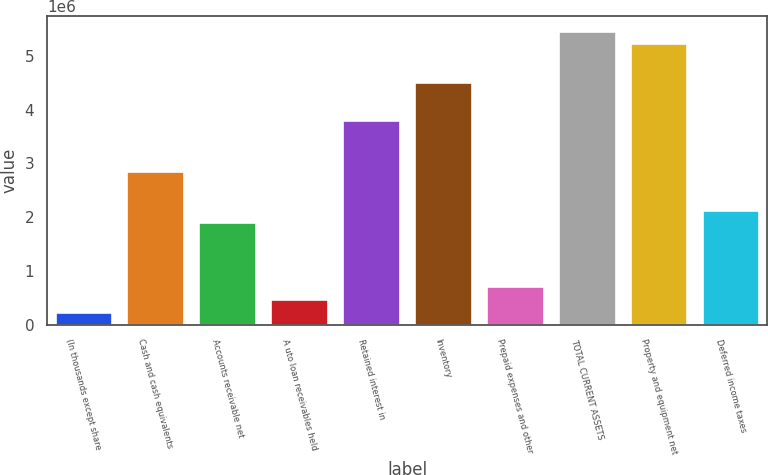Convert chart. <chart><loc_0><loc_0><loc_500><loc_500><bar_chart><fcel>(In thousands except share<fcel>Cash and cash equivalents<fcel>Accounts receivable net<fcel>A uto loan receivables held<fcel>Retained interest in<fcel>Inventory<fcel>Prepaid expenses and other<fcel>TOTAL CURRENT ASSETS<fcel>Property and equipment net<fcel>Deferred income taxes<nl><fcel>238709<fcel>2.85485e+06<fcel>1.90353e+06<fcel>476540<fcel>3.80617e+06<fcel>4.51967e+06<fcel>714371<fcel>5.47099e+06<fcel>5.23316e+06<fcel>2.14136e+06<nl></chart> 